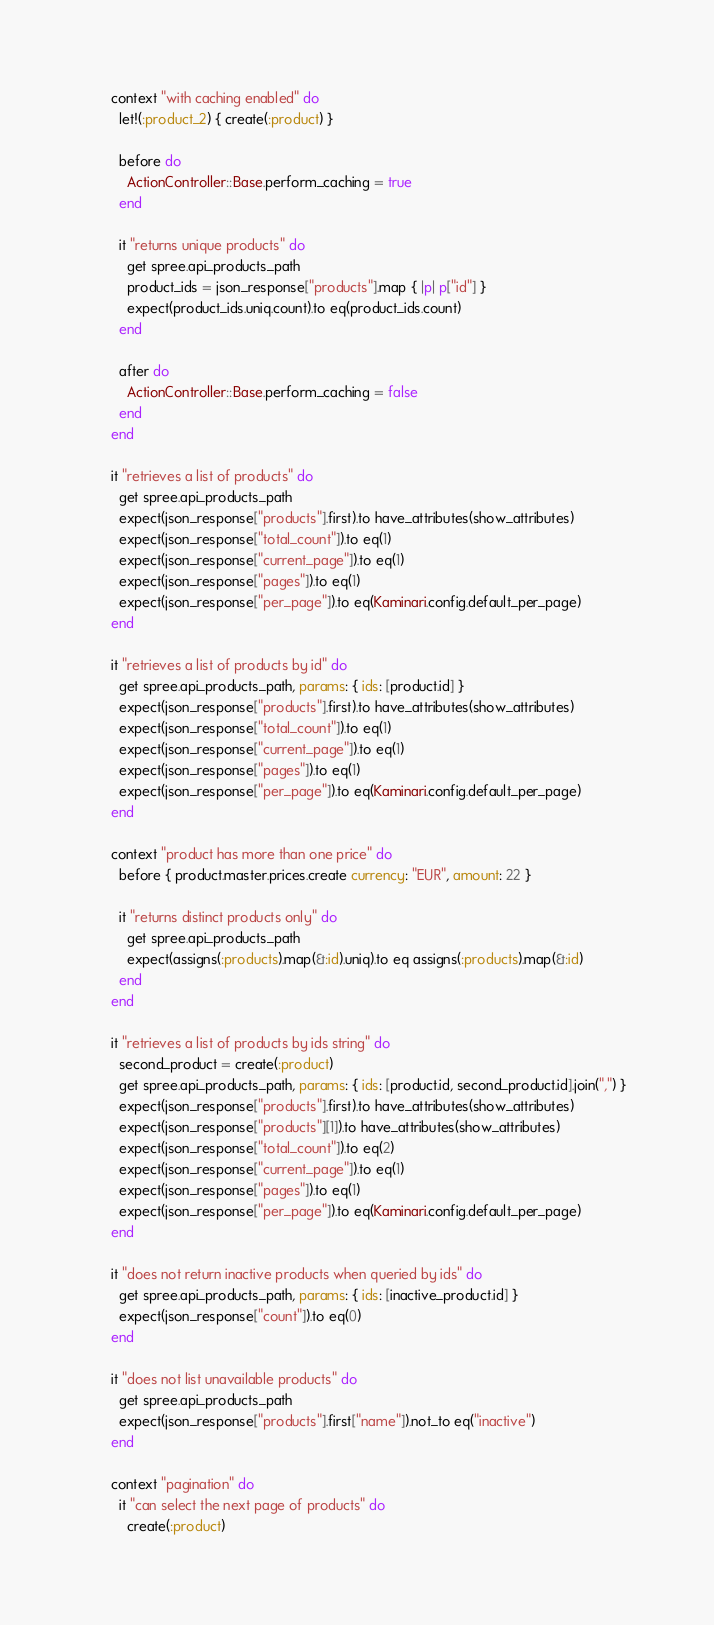Convert code to text. <code><loc_0><loc_0><loc_500><loc_500><_Ruby_>      context "with caching enabled" do
        let!(:product_2) { create(:product) }

        before do
          ActionController::Base.perform_caching = true
        end

        it "returns unique products" do
          get spree.api_products_path
          product_ids = json_response["products"].map { |p| p["id"] }
          expect(product_ids.uniq.count).to eq(product_ids.count)
        end

        after do
          ActionController::Base.perform_caching = false
        end
      end

      it "retrieves a list of products" do
        get spree.api_products_path
        expect(json_response["products"].first).to have_attributes(show_attributes)
        expect(json_response["total_count"]).to eq(1)
        expect(json_response["current_page"]).to eq(1)
        expect(json_response["pages"]).to eq(1)
        expect(json_response["per_page"]).to eq(Kaminari.config.default_per_page)
      end

      it "retrieves a list of products by id" do
        get spree.api_products_path, params: { ids: [product.id] }
        expect(json_response["products"].first).to have_attributes(show_attributes)
        expect(json_response["total_count"]).to eq(1)
        expect(json_response["current_page"]).to eq(1)
        expect(json_response["pages"]).to eq(1)
        expect(json_response["per_page"]).to eq(Kaminari.config.default_per_page)
      end

      context "product has more than one price" do
        before { product.master.prices.create currency: "EUR", amount: 22 }

        it "returns distinct products only" do
          get spree.api_products_path
          expect(assigns(:products).map(&:id).uniq).to eq assigns(:products).map(&:id)
        end
      end

      it "retrieves a list of products by ids string" do
        second_product = create(:product)
        get spree.api_products_path, params: { ids: [product.id, second_product.id].join(",") }
        expect(json_response["products"].first).to have_attributes(show_attributes)
        expect(json_response["products"][1]).to have_attributes(show_attributes)
        expect(json_response["total_count"]).to eq(2)
        expect(json_response["current_page"]).to eq(1)
        expect(json_response["pages"]).to eq(1)
        expect(json_response["per_page"]).to eq(Kaminari.config.default_per_page)
      end

      it "does not return inactive products when queried by ids" do
        get spree.api_products_path, params: { ids: [inactive_product.id] }
        expect(json_response["count"]).to eq(0)
      end

      it "does not list unavailable products" do
        get spree.api_products_path
        expect(json_response["products"].first["name"]).not_to eq("inactive")
      end

      context "pagination" do
        it "can select the next page of products" do
          create(:product)</code> 